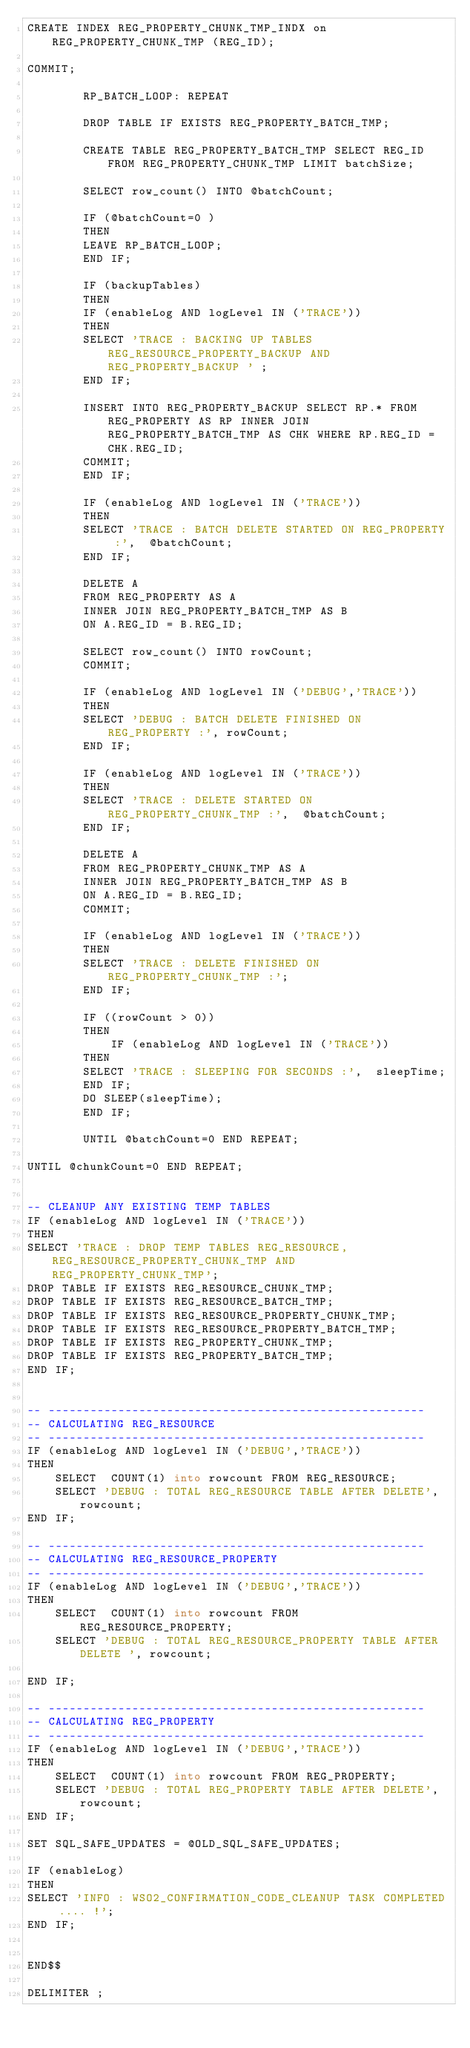<code> <loc_0><loc_0><loc_500><loc_500><_SQL_>CREATE INDEX REG_PROPERTY_CHUNK_TMP_INDX on REG_PROPERTY_CHUNK_TMP (REG_ID);

COMMIT;

        RP_BATCH_LOOP: REPEAT
       
		DROP TABLE IF EXISTS REG_PROPERTY_BATCH_TMP;

        CREATE TABLE REG_PROPERTY_BATCH_TMP SELECT REG_ID FROM REG_PROPERTY_CHUNK_TMP LIMIT batchSize;

        SELECT row_count() INTO @batchCount;
        
		IF (@batchCount=0 )
		THEN
		LEAVE RP_BATCH_LOOP;
		END IF;

        IF (backupTables)
        THEN
        IF (enableLog AND logLevel IN ('TRACE'))
        THEN
        SELECT 'TRACE : BACKING UP TABLES REG_RESOURCE_PROPERTY_BACKUP AND REG_PROPERTY_BACKUP ' ;
        END IF;

        INSERT INTO REG_PROPERTY_BACKUP SELECT RP.* FROM  REG_PROPERTY AS RP INNER JOIN  REG_PROPERTY_BATCH_TMP AS CHK WHERE RP.REG_ID = CHK.REG_ID;
        COMMIT;
        END IF;

        IF (enableLog AND logLevel IN ('TRACE'))
        THEN
        SELECT 'TRACE : BATCH DELETE STARTED ON REG_PROPERTY :',  @batchCount;
        END IF;

        DELETE A
        FROM REG_PROPERTY AS A
        INNER JOIN REG_PROPERTY_BATCH_TMP AS B
        ON A.REG_ID = B.REG_ID;

        SELECT row_count() INTO rowCount;
        COMMIT;

        IF (enableLog AND logLevel IN ('DEBUG','TRACE'))
        THEN
        SELECT 'DEBUG : BATCH DELETE FINISHED ON REG_PROPERTY :', rowCount;
        END IF;

        IF (enableLog AND logLevel IN ('TRACE'))
        THEN
        SELECT 'TRACE : DELETE STARTED ON REG_PROPERTY_CHUNK_TMP :',  @batchCount;
        END IF;

        DELETE A
        FROM REG_PROPERTY_CHUNK_TMP AS A
        INNER JOIN REG_PROPERTY_BATCH_TMP AS B
        ON A.REG_ID = B.REG_ID;
		COMMIT;
        
        IF (enableLog AND logLevel IN ('TRACE'))
        THEN
        SELECT 'TRACE : DELETE FINISHED ON REG_PROPERTY_CHUNK_TMP :';
        END IF;

        IF ((rowCount > 0))
        THEN
            IF (enableLog AND logLevel IN ('TRACE'))
        THEN
        SELECT 'TRACE : SLEEPING FOR SECONDS :',  sleepTime;
        END IF;
        DO SLEEP(sleepTime);
        END IF;

        UNTIL @batchCount=0 END REPEAT;

UNTIL @chunkCount=0 END REPEAT;


-- CLEANUP ANY EXISTING TEMP TABLES
IF (enableLog AND logLevel IN ('TRACE'))
THEN
SELECT 'TRACE : DROP TEMP TABLES REG_RESOURCE, REG_RESOURCE_PROPERTY_CHUNK_TMP AND REG_PROPERTY_CHUNK_TMP';
DROP TABLE IF EXISTS REG_RESOURCE_CHUNK_TMP;
DROP TABLE IF EXISTS REG_RESOURCE_BATCH_TMP;
DROP TABLE IF EXISTS REG_RESOURCE_PROPERTY_CHUNK_TMP;
DROP TABLE IF EXISTS REG_RESOURCE_PROPERTY_BATCH_TMP;
DROP TABLE IF EXISTS REG_PROPERTY_CHUNK_TMP;
DROP TABLE IF EXISTS REG_PROPERTY_BATCH_TMP;
END IF;


-- ------------------------------------------------------
-- CALCULATING REG_RESOURCE
-- ------------------------------------------------------
IF (enableLog AND logLevel IN ('DEBUG','TRACE'))
THEN
    SELECT  COUNT(1) into rowcount FROM REG_RESOURCE;
    SELECT 'DEBUG : TOTAL REG_RESOURCE TABLE AFTER DELETE', rowcount;
END IF;

-- ------------------------------------------------------
-- CALCULATING REG_RESOURCE_PROPERTY
-- ------------------------------------------------------
IF (enableLog AND logLevel IN ('DEBUG','TRACE'))
THEN
    SELECT  COUNT(1) into rowcount FROM REG_RESOURCE_PROPERTY;
    SELECT 'DEBUG : TOTAL REG_RESOURCE_PROPERTY TABLE AFTER DELETE ', rowcount;

END IF;

-- ------------------------------------------------------
-- CALCULATING REG_PROPERTY
-- ------------------------------------------------------
IF (enableLog AND logLevel IN ('DEBUG','TRACE'))
THEN
    SELECT  COUNT(1) into rowcount FROM REG_PROPERTY;
    SELECT 'DEBUG : TOTAL REG_PROPERTY TABLE AFTER DELETE', rowcount;
END IF;

SET SQL_SAFE_UPDATES = @OLD_SQL_SAFE_UPDATES;

IF (enableLog)
THEN
SELECT 'INFO : WSO2_CONFIRMATION_CODE_CLEANUP TASK COMPLETED .... !';
END IF;


END$$

DELIMITER ;
</code> 